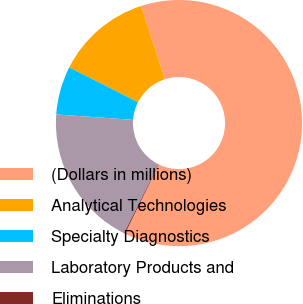Convert chart. <chart><loc_0><loc_0><loc_500><loc_500><pie_chart><fcel>(Dollars in millions)<fcel>Analytical Technologies<fcel>Specialty Diagnostics<fcel>Laboratory Products and<fcel>Eliminations<nl><fcel>62.2%<fcel>12.55%<fcel>6.35%<fcel>18.76%<fcel>0.14%<nl></chart> 